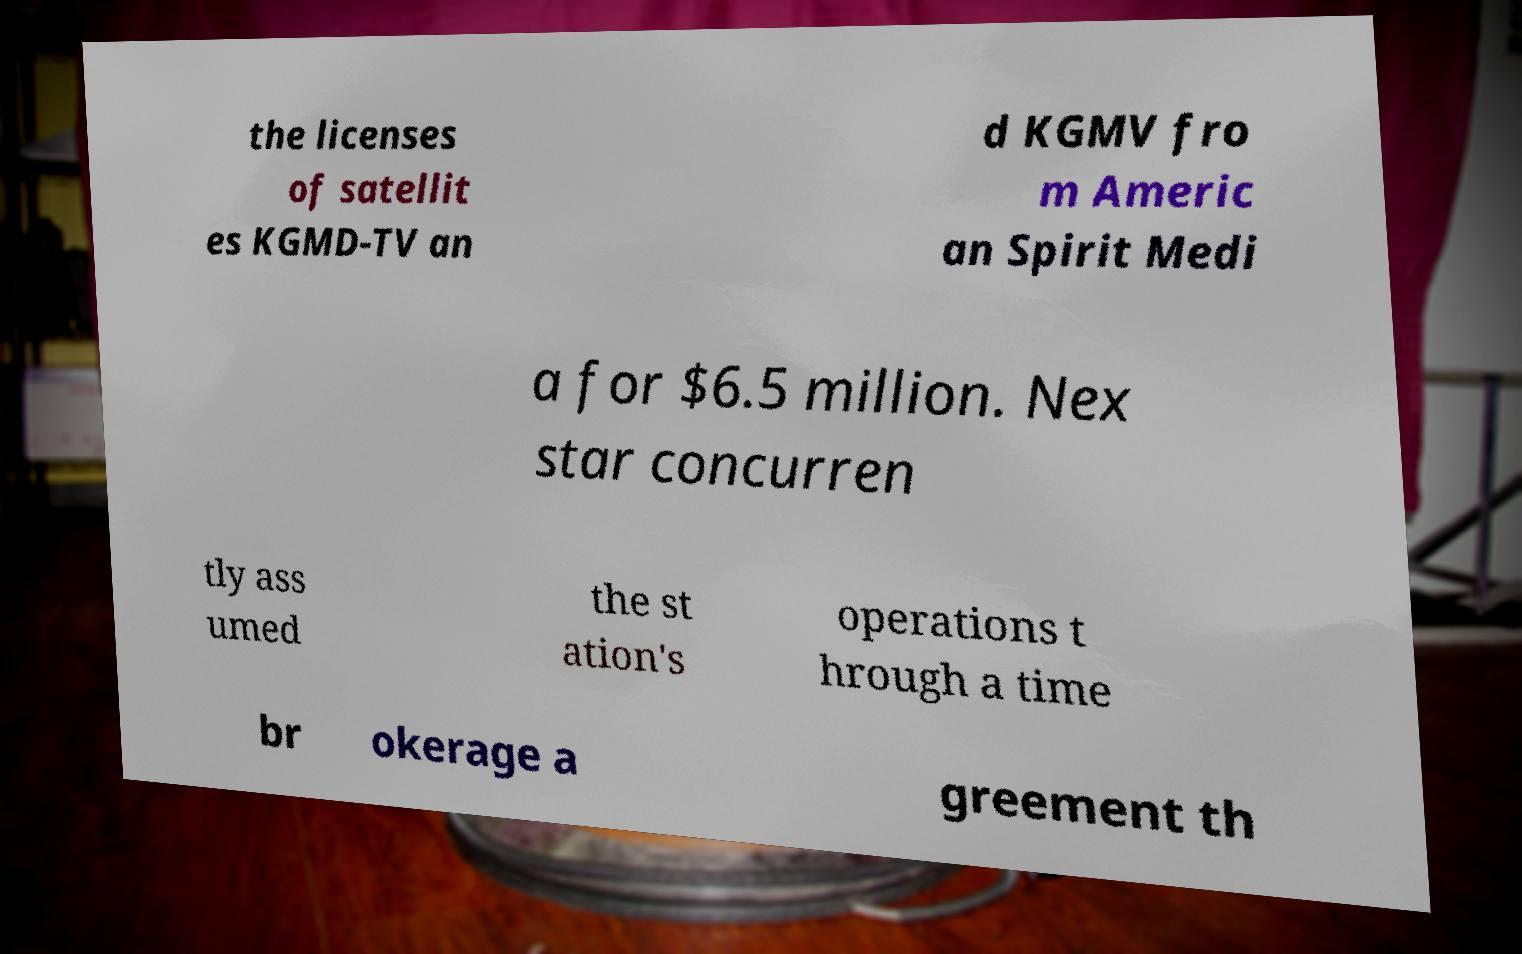I need the written content from this picture converted into text. Can you do that? the licenses of satellit es KGMD-TV an d KGMV fro m Americ an Spirit Medi a for $6.5 million. Nex star concurren tly ass umed the st ation's operations t hrough a time br okerage a greement th 